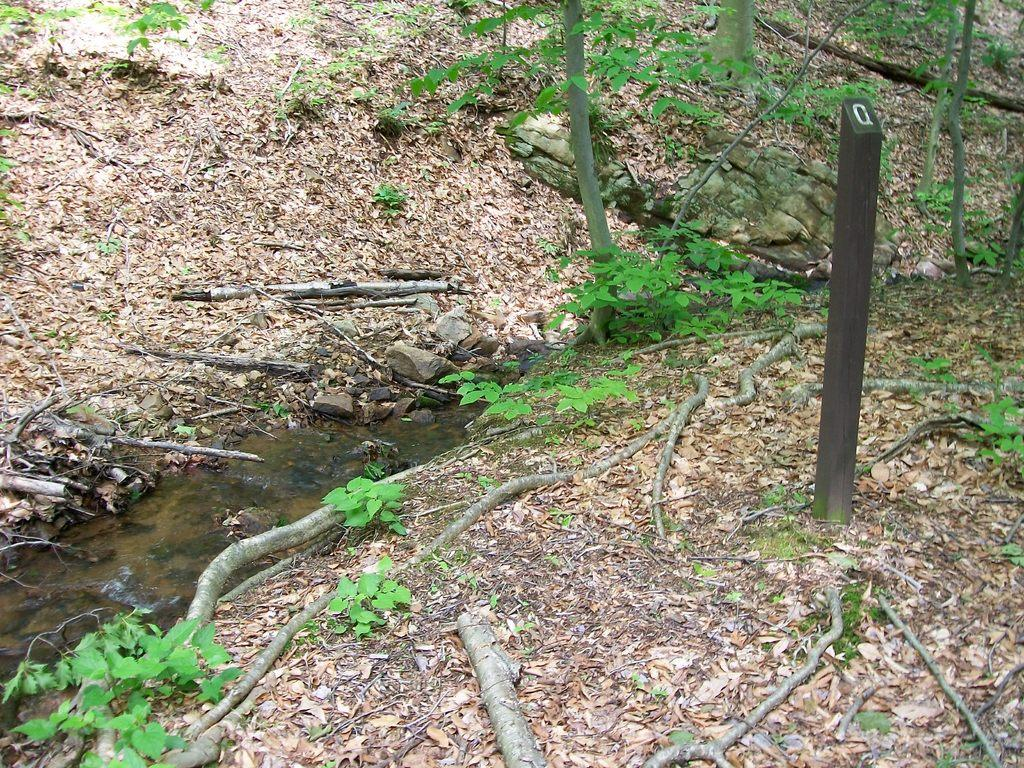What type of living organisms can be seen in the image? Plants can be seen in the image. What material are the sticks in the image made of? The sticks in the image are made of wood. What is the liquid visible in the image? Water is visible in the image. What additional plant material can be seen in the image? Dried leaves are present in the image. What news is the rabbit reading in the image? There is no rabbit present in the image, so it cannot be reading any news. 